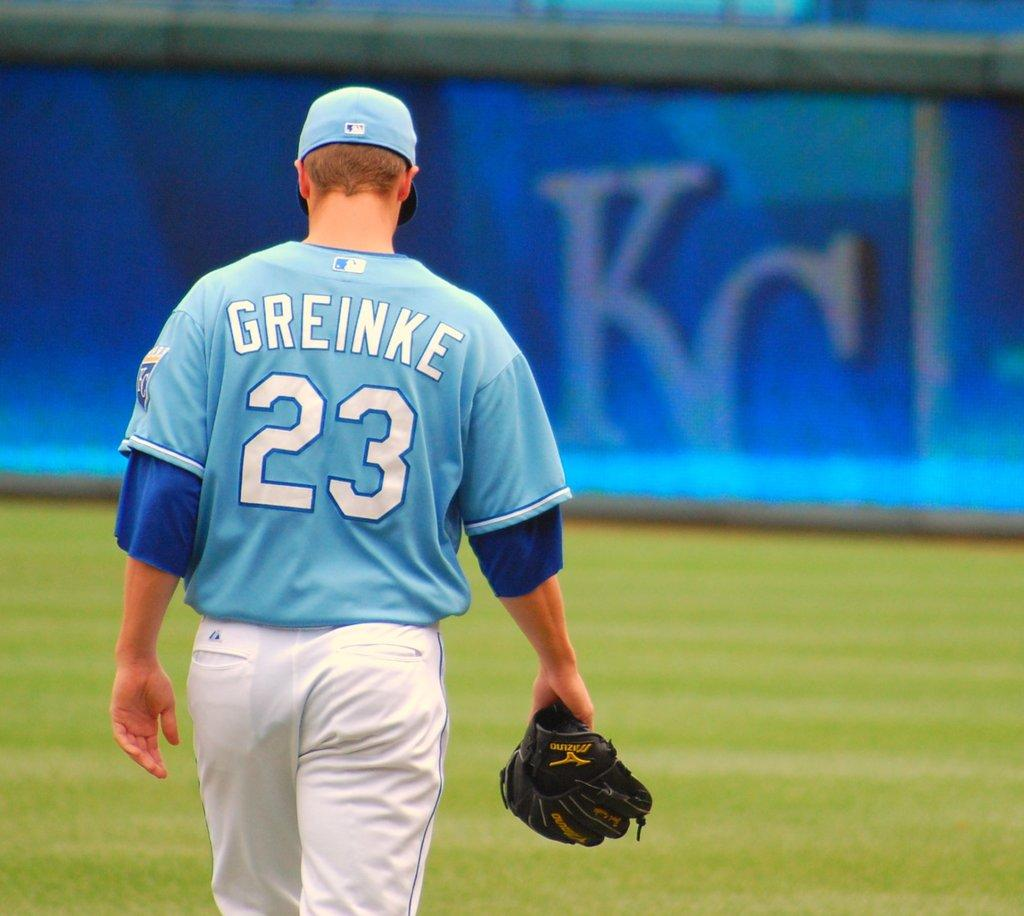<image>
Provide a brief description of the given image. Man wearing a blue jersey which says number 23. 